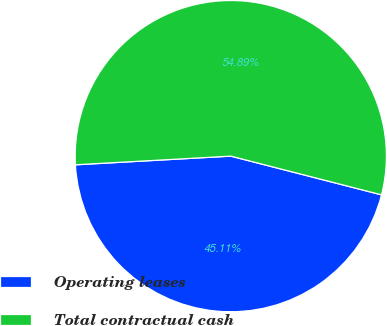Convert chart. <chart><loc_0><loc_0><loc_500><loc_500><pie_chart><fcel>Operating leases<fcel>Total contractual cash<nl><fcel>45.11%<fcel>54.89%<nl></chart> 